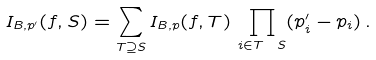<formula> <loc_0><loc_0><loc_500><loc_500>I _ { B , p ^ { \prime } } ( f , S ) = \sum _ { T \supseteq S } I _ { B , p } ( f , T ) \, \prod _ { i \in T \ S } ( p ^ { \prime } _ { i } - p _ { i } ) \, .</formula> 